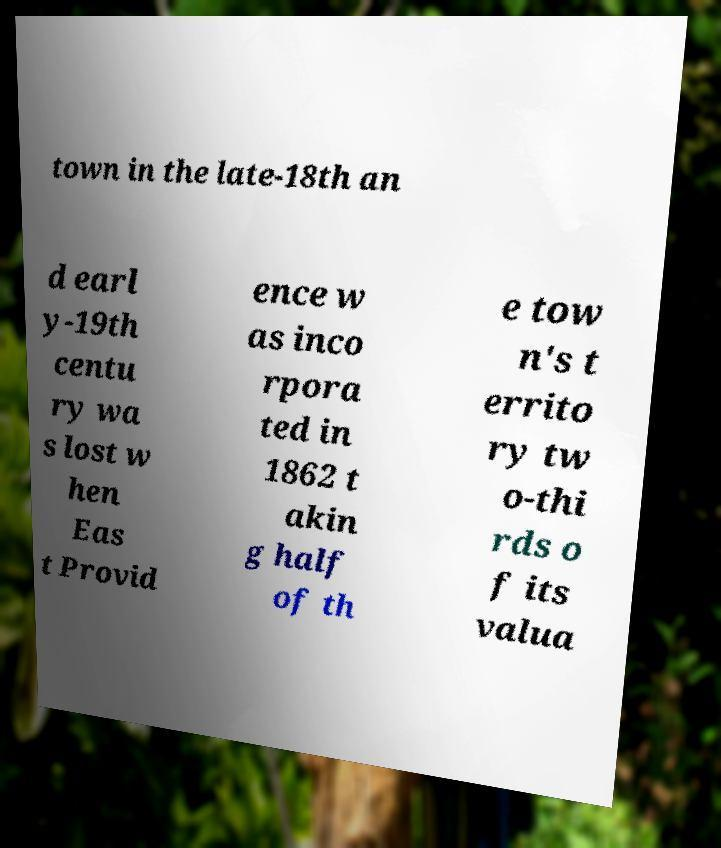Can you read and provide the text displayed in the image?This photo seems to have some interesting text. Can you extract and type it out for me? town in the late-18th an d earl y-19th centu ry wa s lost w hen Eas t Provid ence w as inco rpora ted in 1862 t akin g half of th e tow n's t errito ry tw o-thi rds o f its valua 